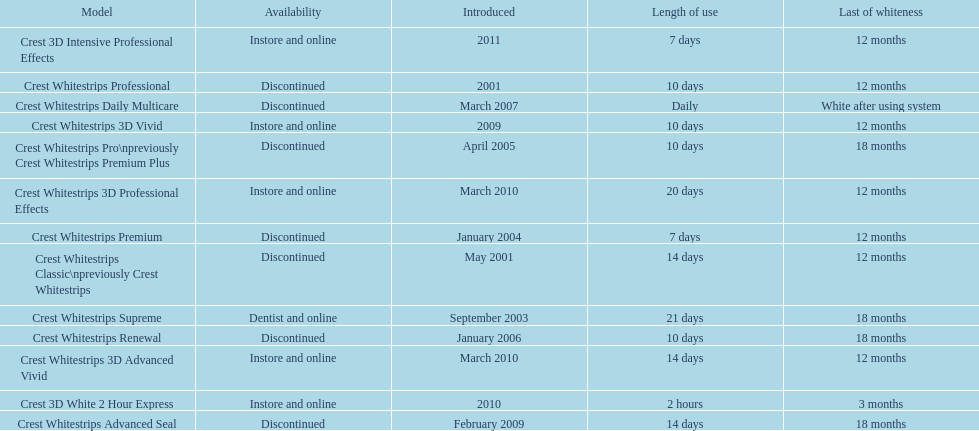Does the crest white strips pro last as long as the crest white strips renewal? Yes. 